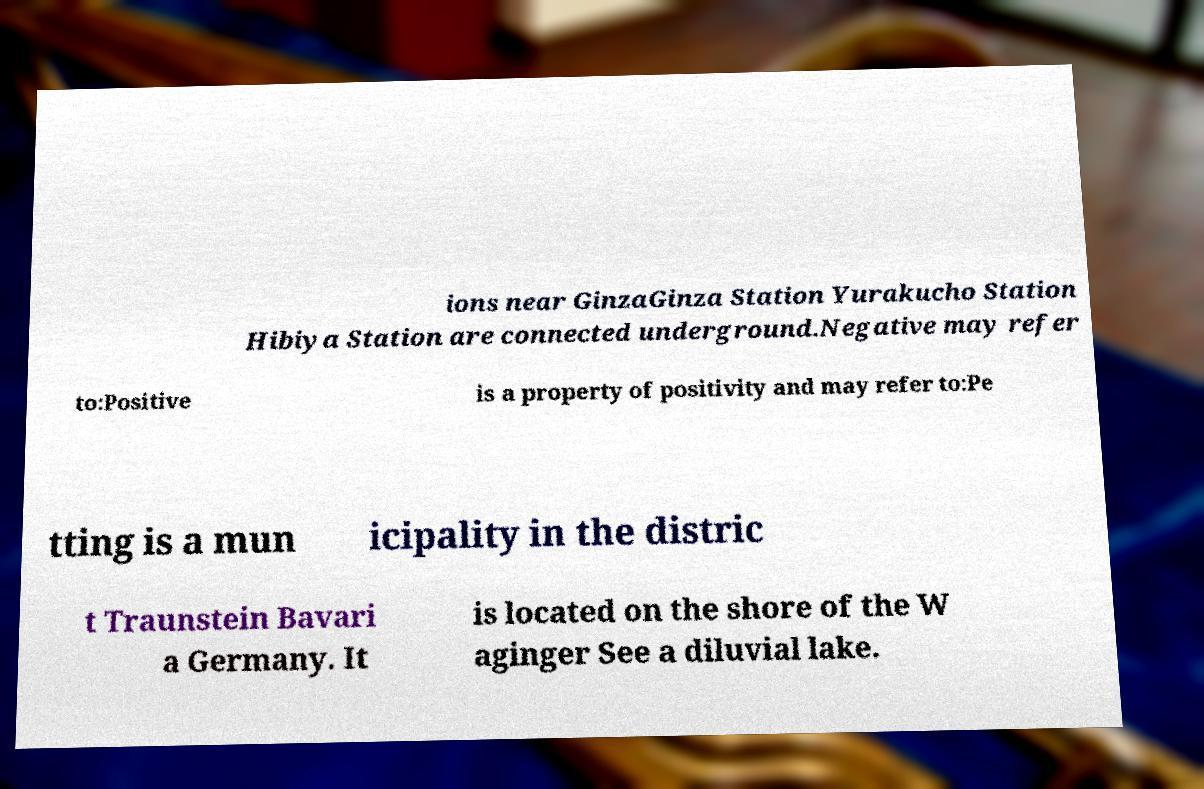There's text embedded in this image that I need extracted. Can you transcribe it verbatim? ions near GinzaGinza Station Yurakucho Station Hibiya Station are connected underground.Negative may refer to:Positive is a property of positivity and may refer to:Pe tting is a mun icipality in the distric t Traunstein Bavari a Germany. It is located on the shore of the W aginger See a diluvial lake. 